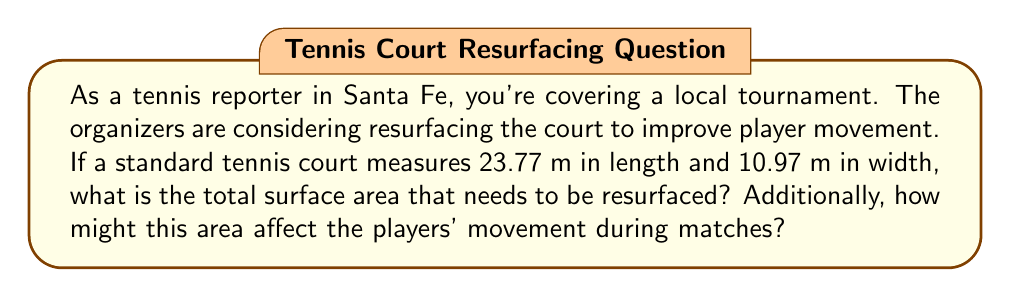Could you help me with this problem? To solve this problem, we'll follow these steps:

1. Calculate the surface area of the tennis court:
   The court is rectangular, so we use the formula for area of a rectangle:
   $$ A = l \times w $$
   Where $A$ is area, $l$ is length, and $w$ is width.

   $$ A = 23.77 \text{ m} \times 10.97 \text{ m} = 260.7569 \text{ m}^2 $$

2. Round the result to two decimal places:
   $$ A \approx 260.76 \text{ m}^2 $$

3. Consider how this area affects player movement:
   - Larger surface area means more ground to cover, requiring greater endurance and speed from players.
   - The dimensions create a rectangular shape, favoring lateral movement along the baseline and quick forward/backward sprints to the net.
   - Players need to consider the boundaries (260.76 m² divided into two equal halves) when positioning and moving during play.
   - Surface type (clay, grass, hard court) on this area will also impact movement, affecting speed, sliding ability, and bounce characteristics.
Answer: 260.76 m²; affects endurance, speed, positioning, and strategy based on court size and surface. 